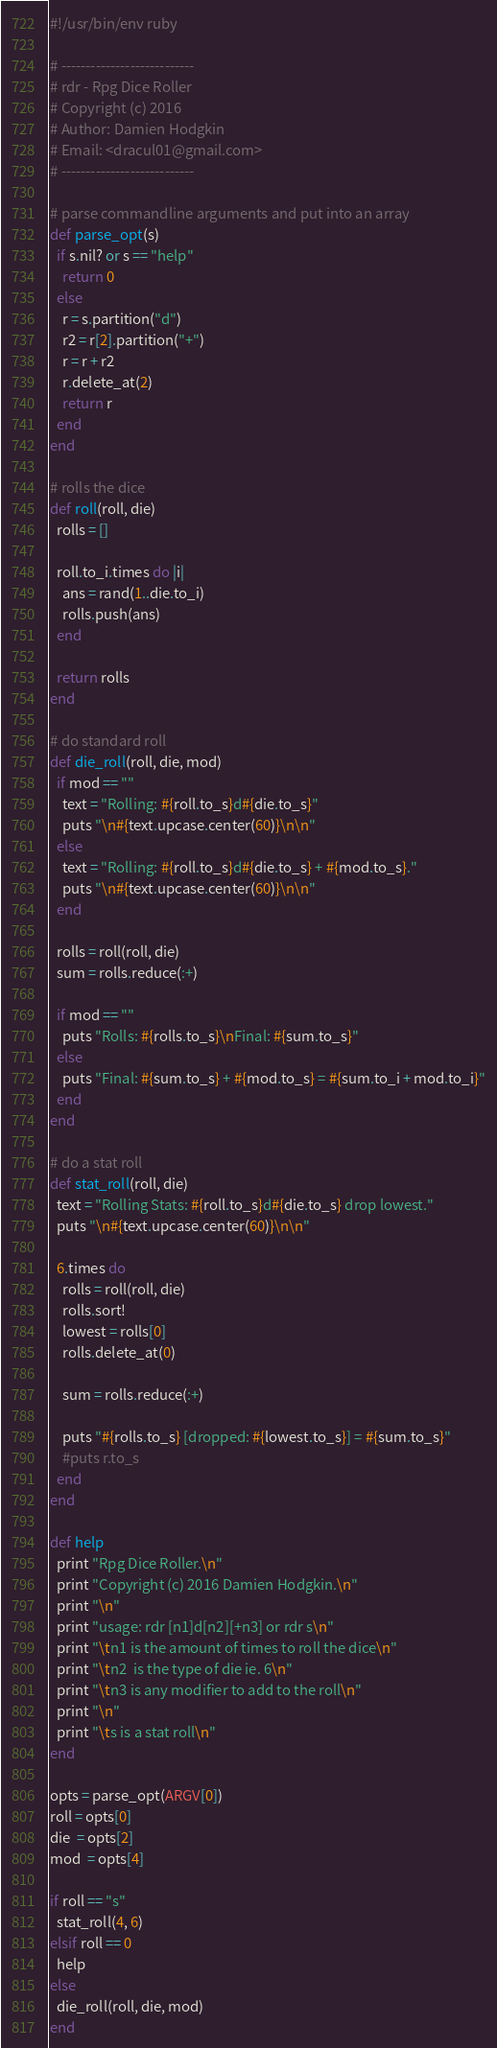Convert code to text. <code><loc_0><loc_0><loc_500><loc_500><_Ruby_>#!/usr/bin/env ruby

# ---------------------------
# rdr - Rpg Dice Roller
# Copyright (c) 2016
# Author: Damien Hodgkin
# Email: <dracul01@gmail.com>
# ---------------------------

# parse commandline arguments and put into an array
def parse_opt(s)
  if s.nil? or s == "help"
    return 0
  else
    r = s.partition("d")
    r2 = r[2].partition("+")
    r = r + r2
    r.delete_at(2)
    return r
  end
end

# rolls the dice
def roll(roll, die)
  rolls = []

  roll.to_i.times do |i|
    ans = rand(1..die.to_i)
    rolls.push(ans)
  end

  return rolls
end

# do standard roll
def die_roll(roll, die, mod)
  if mod == ""
    text = "Rolling: #{roll.to_s}d#{die.to_s}"
    puts "\n#{text.upcase.center(60)}\n\n"
  else
    text = "Rolling: #{roll.to_s}d#{die.to_s} + #{mod.to_s}."
    puts "\n#{text.upcase.center(60)}\n\n"
  end

  rolls = roll(roll, die)
  sum = rolls.reduce(:+)

  if mod == ""
    puts "Rolls: #{rolls.to_s}\nFinal: #{sum.to_s}"
  else
    puts "Final: #{sum.to_s} + #{mod.to_s} = #{sum.to_i + mod.to_i}"
  end
end

# do a stat roll
def stat_roll(roll, die)
  text = "Rolling Stats: #{roll.to_s}d#{die.to_s} drop lowest."
  puts "\n#{text.upcase.center(60)}\n\n"

  6.times do
    rolls = roll(roll, die)
    rolls.sort!
    lowest = rolls[0]
    rolls.delete_at(0)

    sum = rolls.reduce(:+)

    puts "#{rolls.to_s} [dropped: #{lowest.to_s}] = #{sum.to_s}"
    #puts r.to_s
  end
end

def help
  print "Rpg Dice Roller.\n"
  print "Copyright (c) 2016 Damien Hodgkin.\n"
  print "\n"
  print "usage: rdr [n1]d[n2][+n3] or rdr s\n"
  print "\tn1 is the amount of times to roll the dice\n"
  print "\tn2  is the type of die ie. 6\n"
  print "\tn3 is any modifier to add to the roll\n"
  print "\n"
  print "\ts is a stat roll\n"
end

opts = parse_opt(ARGV[0])
roll = opts[0]
die  = opts[2]
mod  = opts[4]

if roll == "s"
  stat_roll(4, 6)
elsif roll == 0
  help
else
  die_roll(roll, die, mod)
end
</code> 